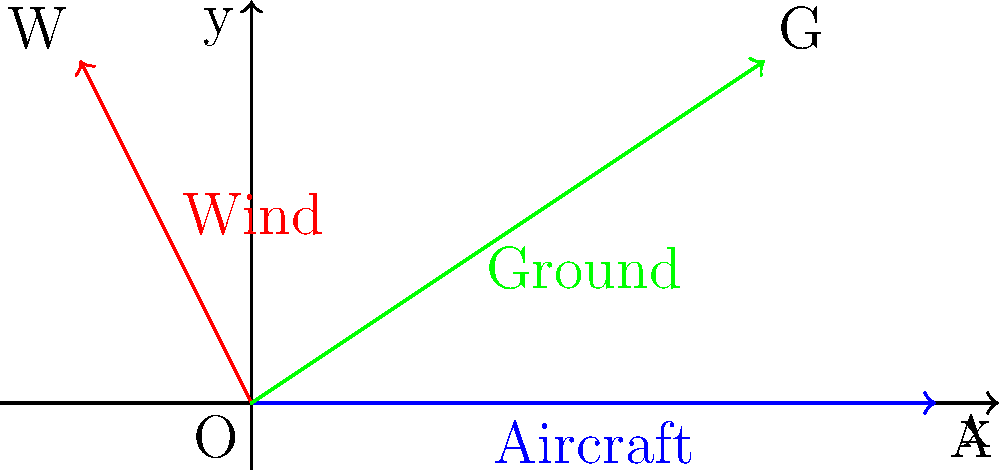Given the aircraft velocity vector of 4 units due east and a wind vector of 1 unit west and 2 units north, calculate the ground speed and heading of the aircraft. Express the heading as an angle counterclockwise from east. To solve this problem, we'll follow these steps:

1. Identify the vectors:
   - Aircraft velocity: $\vec{A} = (4,0)$
   - Wind velocity: $\vec{W} = (-1,2)$

2. Calculate the ground velocity vector:
   $\vec{G} = \vec{A} + \vec{W} = (4,0) + (-1,2) = (3,2)$

3. Calculate the ground speed:
   Ground speed = $\|\vec{G}\| = \sqrt{3^2 + 2^2} = \sqrt{13} \approx 3.61$ units

4. Calculate the heading angle:
   $\theta = \arctan(\frac{y}{x}) = \arctan(\frac{2}{3}) \approx 33.69°$

The ground speed is the magnitude of the ground velocity vector, which is approximately 3.61 units.

The heading is the angle of the ground velocity vector measured counterclockwise from east (positive x-axis), which is approximately 33.69°.
Answer: Ground speed: $\sqrt{13}$ units, Heading: $\arctan(\frac{2}{3})$ degrees 